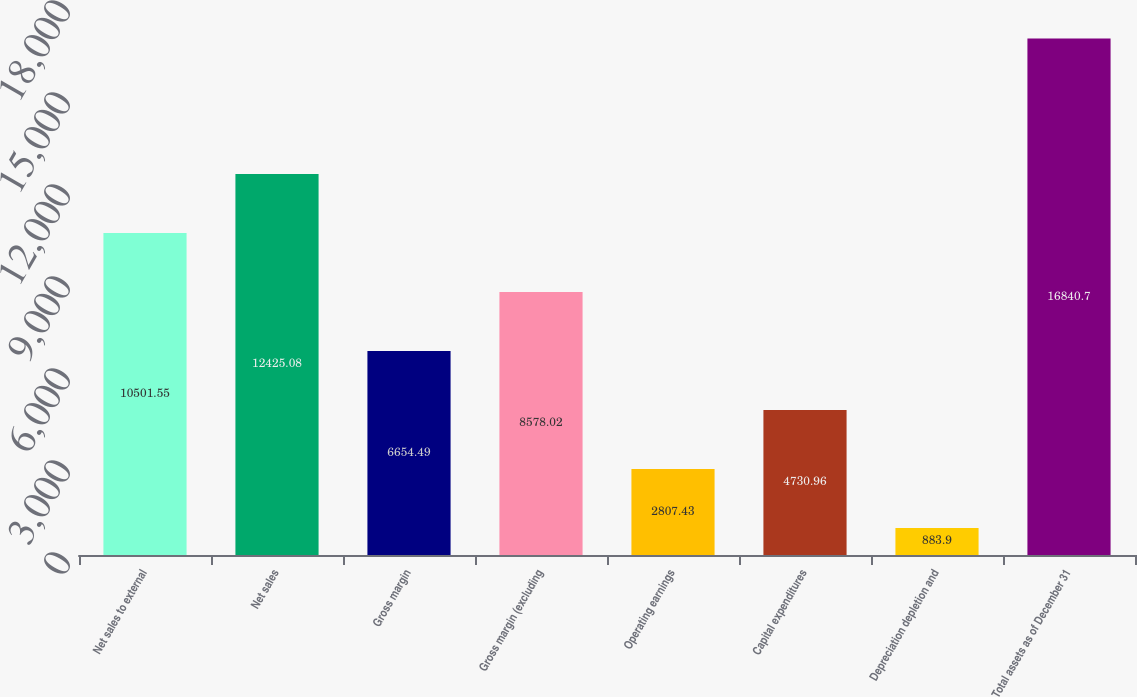Convert chart to OTSL. <chart><loc_0><loc_0><loc_500><loc_500><bar_chart><fcel>Net sales to external<fcel>Net sales<fcel>Gross margin<fcel>Gross margin (excluding<fcel>Operating earnings<fcel>Capital expenditures<fcel>Depreciation depletion and<fcel>Total assets as of December 31<nl><fcel>10501.5<fcel>12425.1<fcel>6654.49<fcel>8578.02<fcel>2807.43<fcel>4730.96<fcel>883.9<fcel>16840.7<nl></chart> 